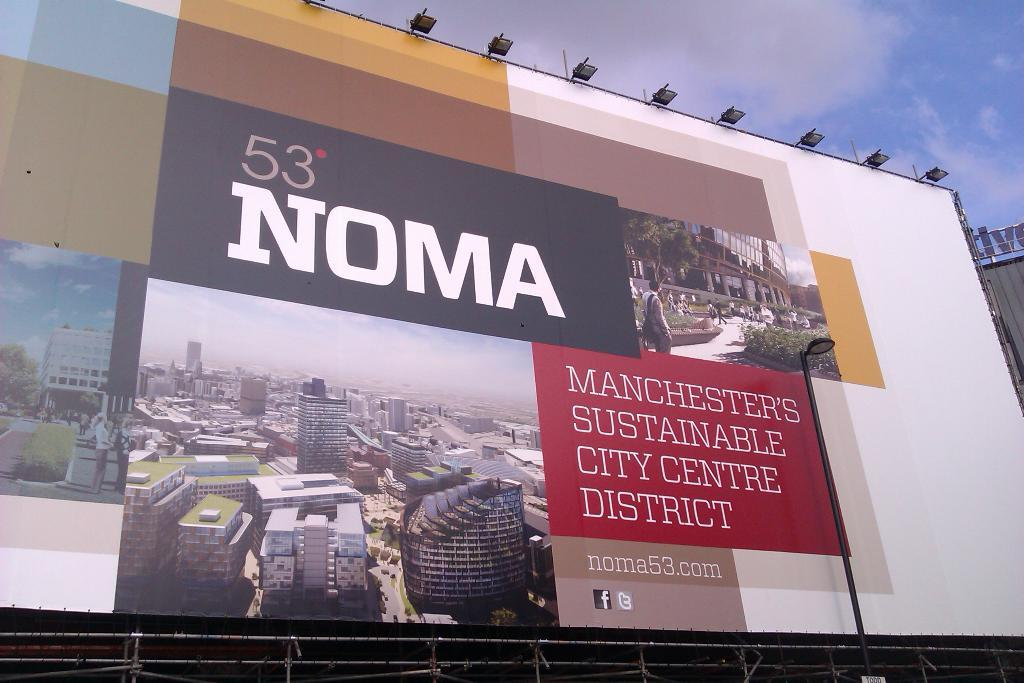<image>
Offer a succinct explanation of the picture presented. a billboard for 53 NOMA Manchester's Sustainable City Centre District 